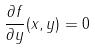<formula> <loc_0><loc_0><loc_500><loc_500>\frac { \partial f } { \partial y } ( x , y ) = 0</formula> 